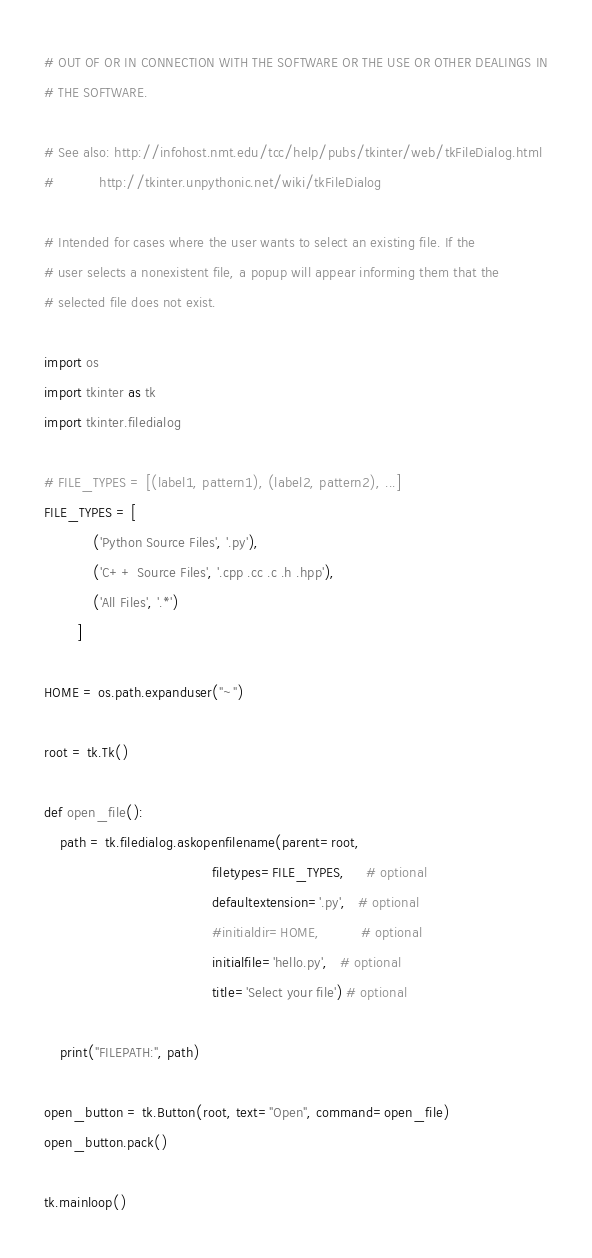Convert code to text. <code><loc_0><loc_0><loc_500><loc_500><_Python_># OUT OF OR IN CONNECTION WITH THE SOFTWARE OR THE USE OR OTHER DEALINGS IN
# THE SOFTWARE.

# See also: http://infohost.nmt.edu/tcc/help/pubs/tkinter/web/tkFileDialog.html
#           http://tkinter.unpythonic.net/wiki/tkFileDialog

# Intended for cases where the user wants to select an existing file. If the
# user selects a nonexistent file, a popup will appear informing them that the
# selected file does not exist. 

import os
import tkinter as tk
import tkinter.filedialog

# FILE_TYPES = [(label1, pattern1), (label2, pattern2), ...]
FILE_TYPES = [
            ('Python Source Files', '.py'),
            ('C++ Source Files', '.cpp .cc .c .h .hpp'),
            ('All Files', '.*')
        ]

HOME = os.path.expanduser("~")

root = tk.Tk()

def open_file():
    path = tk.filedialog.askopenfilename(parent=root,
                                         filetypes=FILE_TYPES,     # optional
                                         defaultextension='.py',   # optional
                                         #initialdir=HOME,          # optional
                                         initialfile='hello.py',   # optional
                                         title='Select your file') # optional

    print("FILEPATH:", path)

open_button = tk.Button(root, text="Open", command=open_file)
open_button.pack()

tk.mainloop()

</code> 